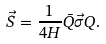<formula> <loc_0><loc_0><loc_500><loc_500>\vec { S } = \frac { 1 } { 4 H } \bar { Q } \vec { \sigma } Q .</formula> 